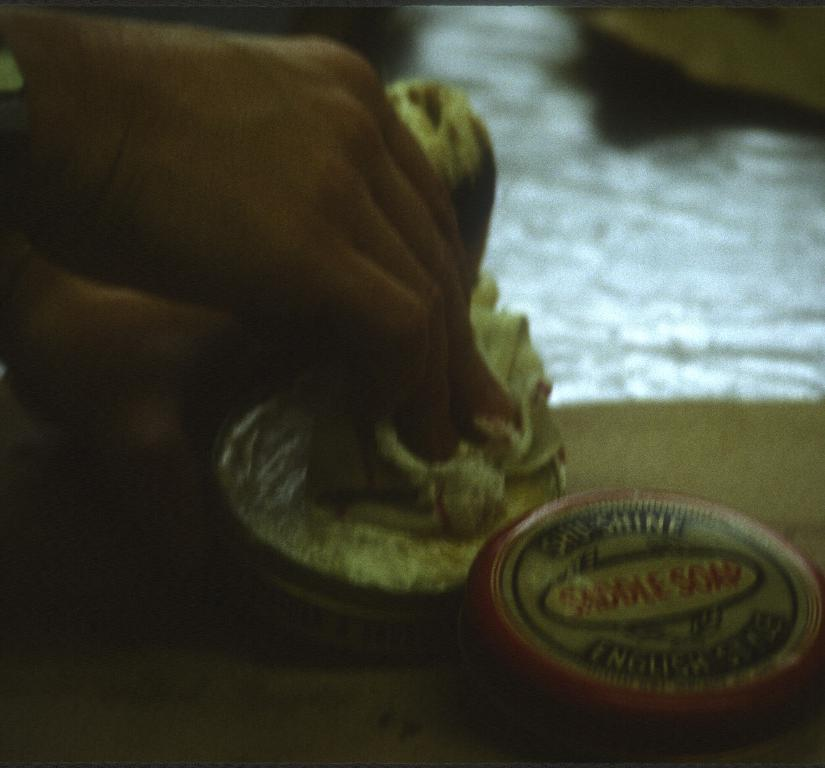What is being held by the human hand in the image? There is a human hand holding a cloth in the image. What can be seen at the bottom of the image? There is an object at the bottom of the image. What type of note is being played by the donkey in the image? There is no donkey or note being played in the image; it only features a human hand holding a cloth and an object at the bottom. 